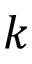Convert formula to latex. <formula><loc_0><loc_0><loc_500><loc_500>k</formula> 